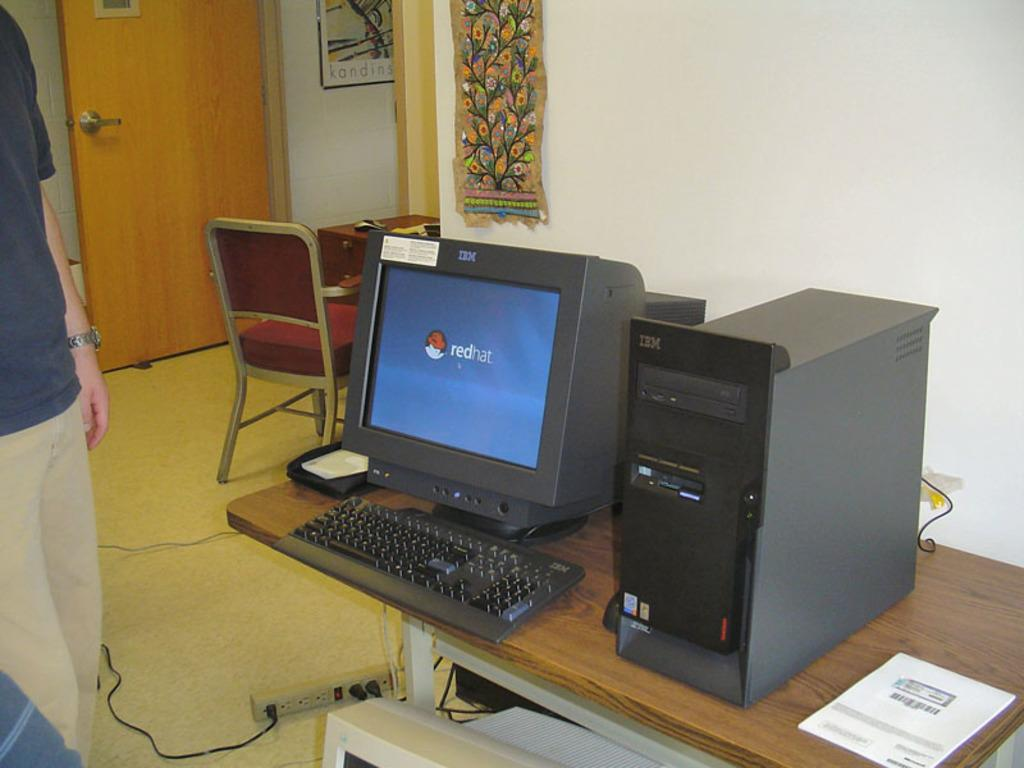What electronic device is visible in the image? There is a monitor in the image. What other computer components can be seen in the image? There is a keyboard and a CPU in the image. Where are these items located? These items are on a table. Is there anyone present in the image? Yes, there is a person standing in the image. What can be seen in the background of the image? There is a chair and a door in the background of the image. What type of band is playing in the image? There is no band present in the image; it features computer components and a person standing near them. What button is being pushed by the person in the image? There is no button being pushed by the person in the image; they are simply standing near the computer components. 